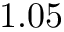<formula> <loc_0><loc_0><loc_500><loc_500>1 . 0 5</formula> 